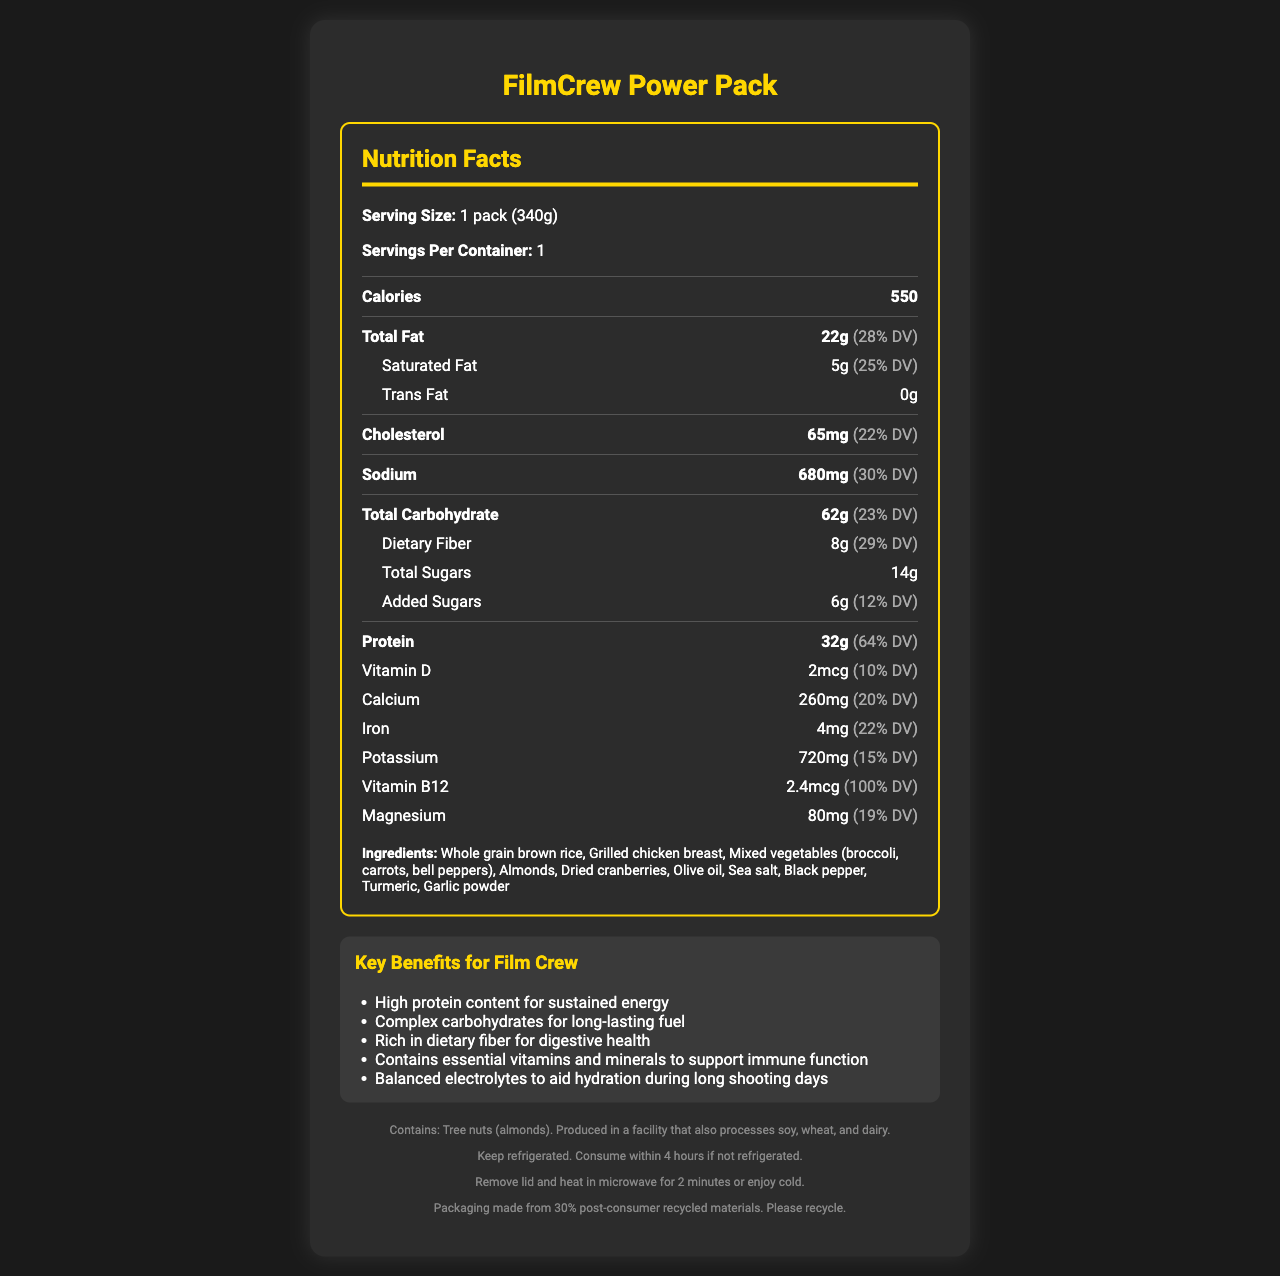what is the serving size of the FilmCrew Power Pack? The serving size is stated at the beginning of the Nutrition Facts section.
Answer: 1 pack (340g) how many calories are in one serving? The document states that each pack contains 550 calories.
Answer: 550 what is the total fat content per serving? The total fat content is listed as 22g with a daily value of 28%.
Answer: 22g how much dietary fiber is in the FilmCrew Power Pack? The dietary fiber content is specified as 8g with a daily value of 29%.
Answer: 8g what type of container is used for packaging? This information is provided under the packaging section.
Answer: BPA-free, microwave-safe container with easy-open lid how much protein does one pack contain? A. 20g B. 32g C. 50g D. 64g The protein content is clearly listed as 32g with a daily value of 64%.
Answer: B. 32g how should the FilmCrew Power Pack be stored? A. Keep at room temperature B. Freeze C. Refrigerate D. Store in a cool, dark place The storage instructions state that it should be kept refrigerated and consumed within 4 hours if not refrigerated.
Answer: C. Refrigerate is this product suitable for someone with a tree nut allergy? The allergen information states that it contains tree nuts (almonds).
Answer: No does the product contain any trans fat? The document specifies that trans fat content is 0g.
Answer: No summarize the key benefits of the FilmCrew Power Pack for the target audience. These benefits are listed in the key benefits section, which is directed towards film crew members, including boom operators and sound engineers.
Answer: The FilmCrew Power Pack provides high protein content for sustained energy, complex carbohydrates for long-lasting fuel, rich dietary fiber for digestive health, essential vitamins and minerals to support immune function, and balanced electrolytes to aid hydration during long shooting days. what is the amount of vitamin B12 in the FilmCrew Power Pack? The document lists vitamin B12 at 2.4mcg with a daily value of 100%.
Answer: 2.4mcg are there any added sugars in this product? The document specifies that there are 6g of added sugars with a daily value of 12%.
Answer: Yes how many grams of total carbohydrates does one serving have? The total carbohydrates per serving are listed as 62g with a daily value of 23%.
Answer: 62g how long should the FilmCrew Power Pack be heated in a microwave? The heating instructions state to remove the lid and heat in microwave for 2 minutes.
Answer: 2 minutes what is the main ingredient in the FilmCrew Power Pack? A. Grilled chicken breast B. Whole grain brown rice C. Mixed vegetables D. Almonds The first ingredient listed is whole grain brown rice, indicating that it is the main ingredient.
Answer: B. Whole grain brown rice what mineral content in the product contributes to 15% of the daily value? The potassium content is listed as 720mg with a daily value of 15%.
Answer: Potassium why might a worker in the film crew choose this meal for a break? The key benefits section explains why this meal is designed for film crew members with limited break times.
Answer: The FilmCrew Power Pack provides sustained energy through high protein content, long-lasting fuel from complex carbohydrates, rich dietary fiber for digestive health, essential vitamins and minerals for immune support, and balanced electrolytes for hydration. how much vitamin D is in the FilmCrew Power Pack? The vitamin D content is 2mcg with a daily value of 10%.
Answer: 2mcg what should you do if the FilmCrew Power Pack is not refrigerated? The storage instructions specify to consume within 4 hours if not refrigerated.
Answer: Consume within 4 hours does the packaging use any recycled materials? The sustainability note mentions that the packaging is made from 30% post-consumer recycled materials.
Answer: Yes what company produced the FilmCrew Power Pack? The document does not provide any information about the company that produced the FilmCrew Power Pack.
Answer: Cannot be determined 